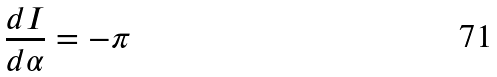Convert formula to latex. <formula><loc_0><loc_0><loc_500><loc_500>\frac { d I } { d \alpha } = - \pi</formula> 